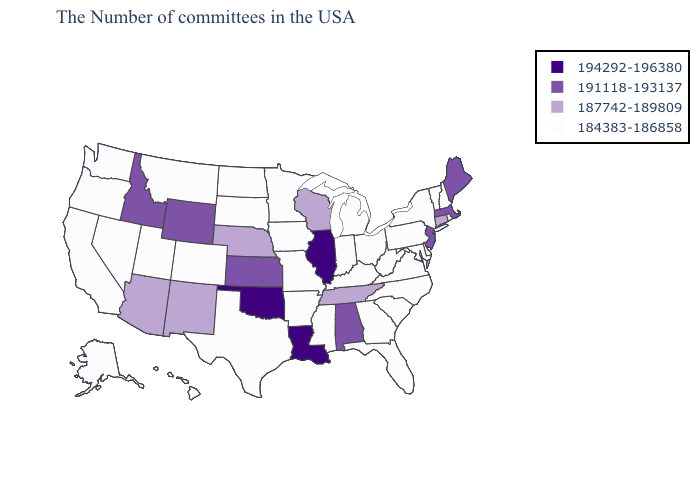What is the highest value in the USA?
Short answer required. 194292-196380. Name the states that have a value in the range 187742-189809?
Keep it brief. Connecticut, Tennessee, Wisconsin, Nebraska, New Mexico, Arizona. What is the highest value in the West ?
Be succinct. 191118-193137. Among the states that border New Mexico , does Arizona have the highest value?
Write a very short answer. No. Does Minnesota have the same value as Arizona?
Write a very short answer. No. Among the states that border California , which have the lowest value?
Quick response, please. Nevada, Oregon. Among the states that border Maine , which have the lowest value?
Keep it brief. New Hampshire. Among the states that border Connecticut , which have the highest value?
Give a very brief answer. Massachusetts. Among the states that border New York , does Massachusetts have the highest value?
Concise answer only. Yes. What is the value of Tennessee?
Be succinct. 187742-189809. Among the states that border Nevada , which have the highest value?
Quick response, please. Idaho. Does Massachusetts have a lower value than Rhode Island?
Be succinct. No. Name the states that have a value in the range 184383-186858?
Keep it brief. Rhode Island, New Hampshire, Vermont, New York, Delaware, Maryland, Pennsylvania, Virginia, North Carolina, South Carolina, West Virginia, Ohio, Florida, Georgia, Michigan, Kentucky, Indiana, Mississippi, Missouri, Arkansas, Minnesota, Iowa, Texas, South Dakota, North Dakota, Colorado, Utah, Montana, Nevada, California, Washington, Oregon, Alaska, Hawaii. What is the value of Maryland?
Concise answer only. 184383-186858. Does Louisiana have a higher value than Oregon?
Write a very short answer. Yes. 